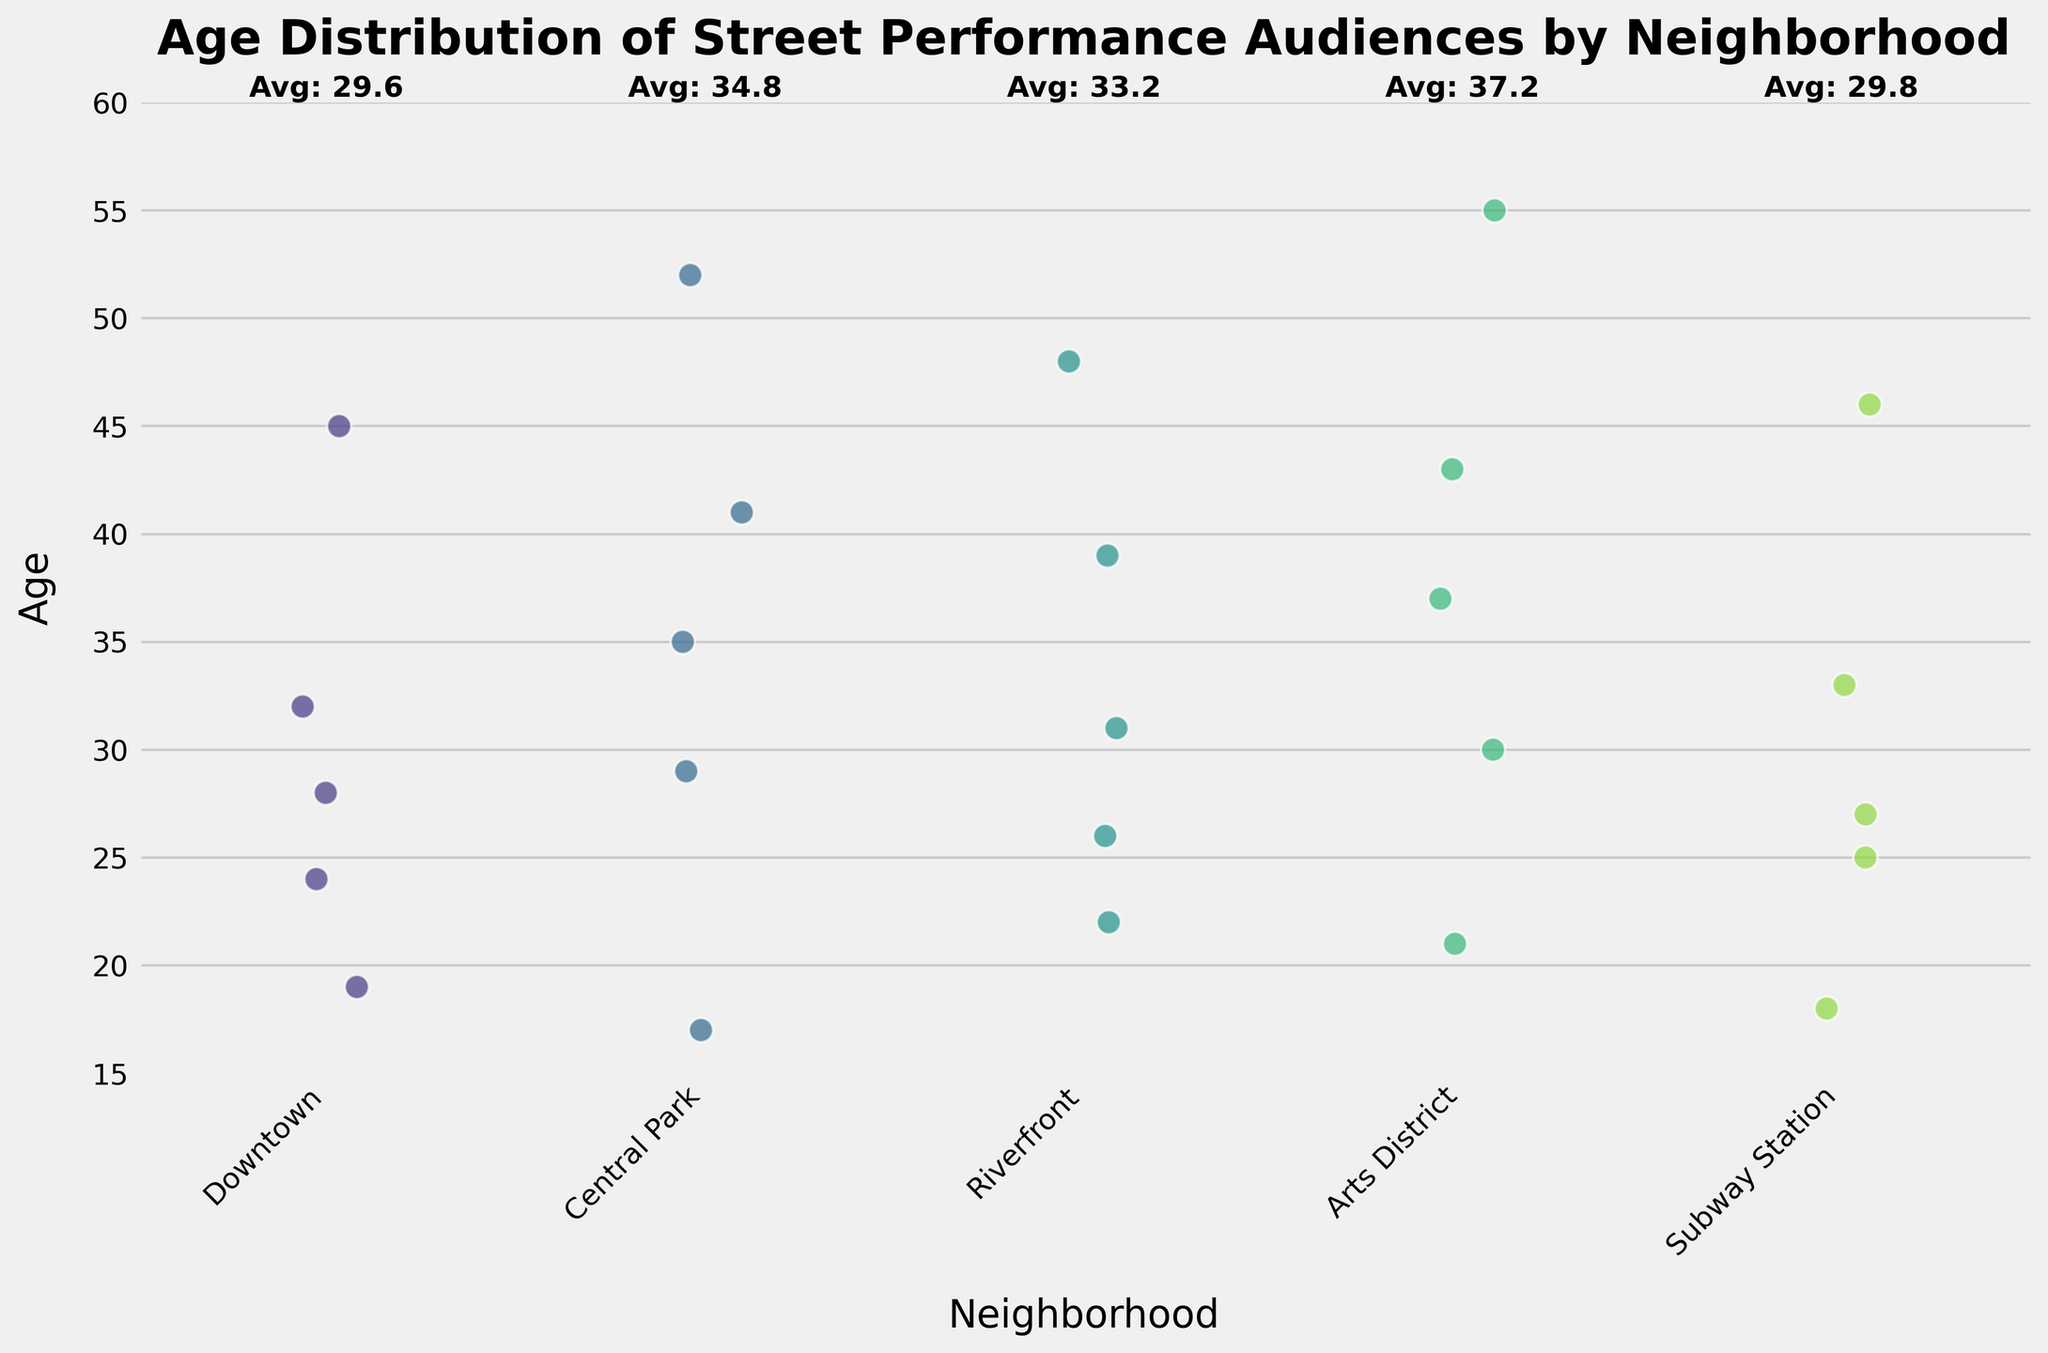What is the title of the plot? The title appears at the top center of the plot, typically in a larger and bold font.
Answer: Age Distribution of Street Performance Audiences by Neighborhood What are the labels on the x-axis and y-axis? The labels are visibly stated on the x-axis and y-axis of the plot. The x-axis label indicates 'Neighborhood' and the y-axis label indicates 'Age.'
Answer: Neighborhood (x-axis) and Age (y-axis) How many age data points are represented for the Downtown neighborhood? By counting the individual dots that are plotted over the 'Downtown' label on the x-axis, we can determine the number of data points. There are five data points.
Answer: Five Which neighborhood has the widest spread in age demographics? To determine the widest spread, observe the range from the lowest to the highest point within each neighborhood on the y-axis. 'Arts District' shows ages from 21 to 55, which is the widest spread.
Answer: Arts District Which neighborhood has the highest average age of the audience? The figure includes text labels above the plot areas that display the average age for each neighborhood. By reading these values, 'Arts District' has the highest average age of 37.2.
Answer: Arts District What is the age of the youngest audience member? Look at the minimum point on the y-axis across all neighborhoods. The lowest visible point is at age 17 in Central Park.
Answer: 17 Which two neighborhoods have the closest average audience ages? Compare the average age text labels above each neighborhood's plot area. 'Riverfront’ (33.2) and 'Central Park' (34.8) have the closest average audience ages.
Answer: Riverfront and Central Park Is there any neighborhood where the audience's ages do not exceed 50? Look for neighborhoods where the top-most dot is below or at the 50 mark on the y-axis. 'Downtown' and 'Subway Station' do not have audience ages exceeding 50.
Answer: Downtown and Subway Station Which neighborhood has the audience member with the highest age? By scanning the highest point along the y-axis for each neighborhood, 'Arts District' has an audience member aged 55, which is the highest.
Answer: Arts District 